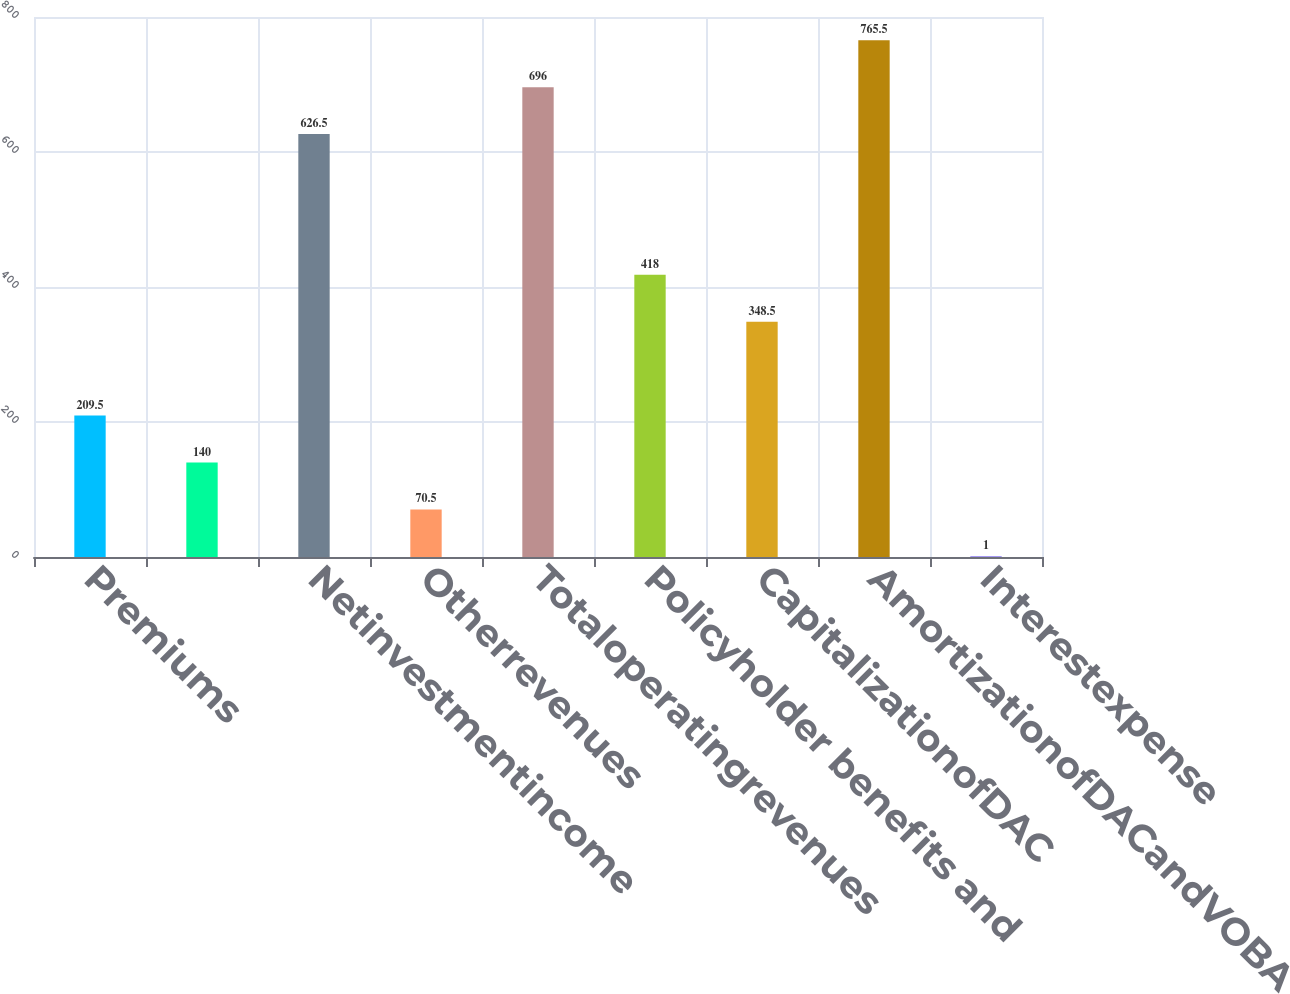Convert chart. <chart><loc_0><loc_0><loc_500><loc_500><bar_chart><fcel>Premiums<fcel>Unnamed: 1<fcel>Netinvestmentincome<fcel>Otherrevenues<fcel>Totaloperatingrevenues<fcel>Policyholder benefits and<fcel>CapitalizationofDAC<fcel>AmortizationofDACandVOBA<fcel>Interestexpense<nl><fcel>209.5<fcel>140<fcel>626.5<fcel>70.5<fcel>696<fcel>418<fcel>348.5<fcel>765.5<fcel>1<nl></chart> 